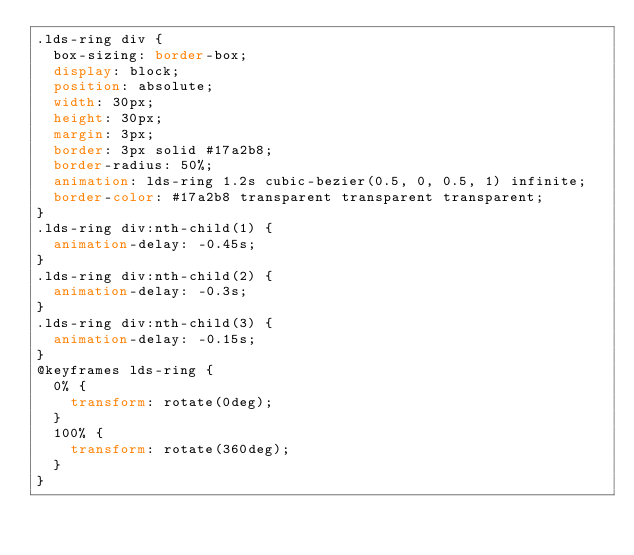Convert code to text. <code><loc_0><loc_0><loc_500><loc_500><_CSS_>.lds-ring div {
  box-sizing: border-box;
  display: block;
  position: absolute;
  width: 30px;
  height: 30px;
  margin: 3px;
  border: 3px solid #17a2b8;
  border-radius: 50%;
  animation: lds-ring 1.2s cubic-bezier(0.5, 0, 0.5, 1) infinite;
  border-color: #17a2b8 transparent transparent transparent;
}
.lds-ring div:nth-child(1) {
  animation-delay: -0.45s;
}
.lds-ring div:nth-child(2) {
  animation-delay: -0.3s;
}
.lds-ring div:nth-child(3) {
  animation-delay: -0.15s;
}
@keyframes lds-ring {
  0% {
    transform: rotate(0deg);
  }
  100% {
    transform: rotate(360deg);
  }
}</code> 